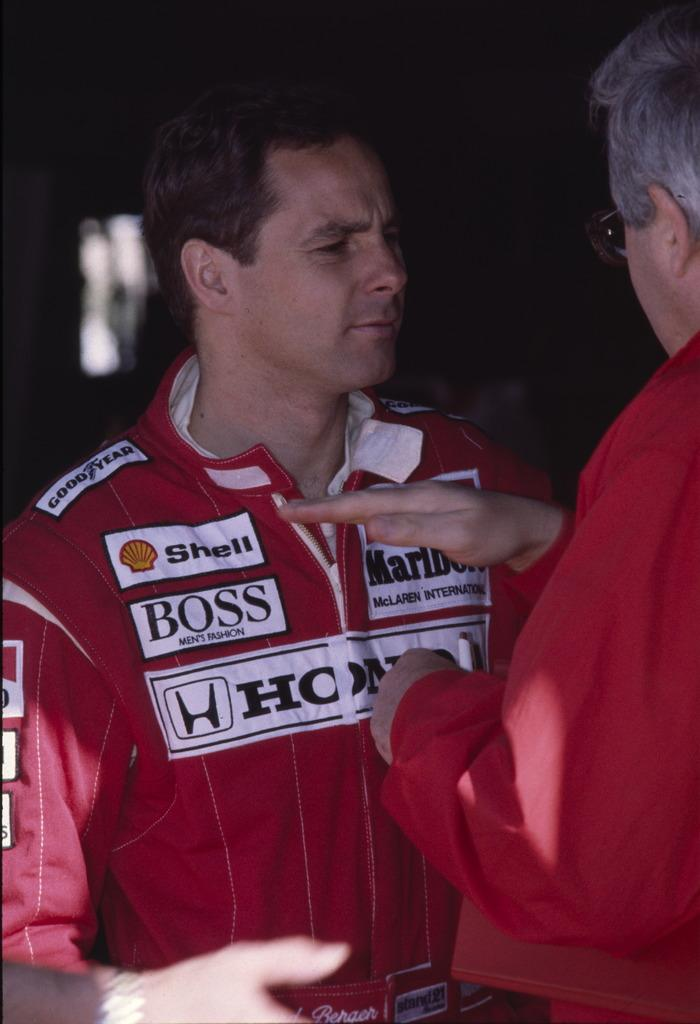<image>
Describe the image concisely. A man in a red jacket has many brands on his uniform, including Boss and Shell. 